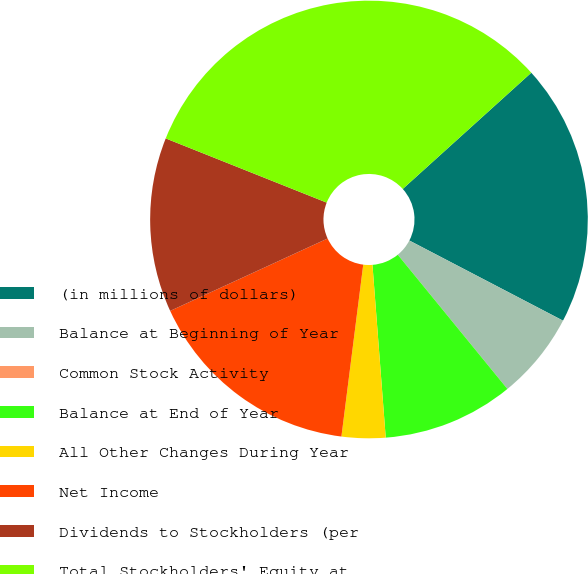Convert chart. <chart><loc_0><loc_0><loc_500><loc_500><pie_chart><fcel>(in millions of dollars)<fcel>Balance at Beginning of Year<fcel>Common Stock Activity<fcel>Balance at End of Year<fcel>All Other Changes During Year<fcel>Net Income<fcel>Dividends to Stockholders (per<fcel>Total Stockholders' Equity at<nl><fcel>19.35%<fcel>6.45%<fcel>0.0%<fcel>9.68%<fcel>3.23%<fcel>16.13%<fcel>12.9%<fcel>32.26%<nl></chart> 